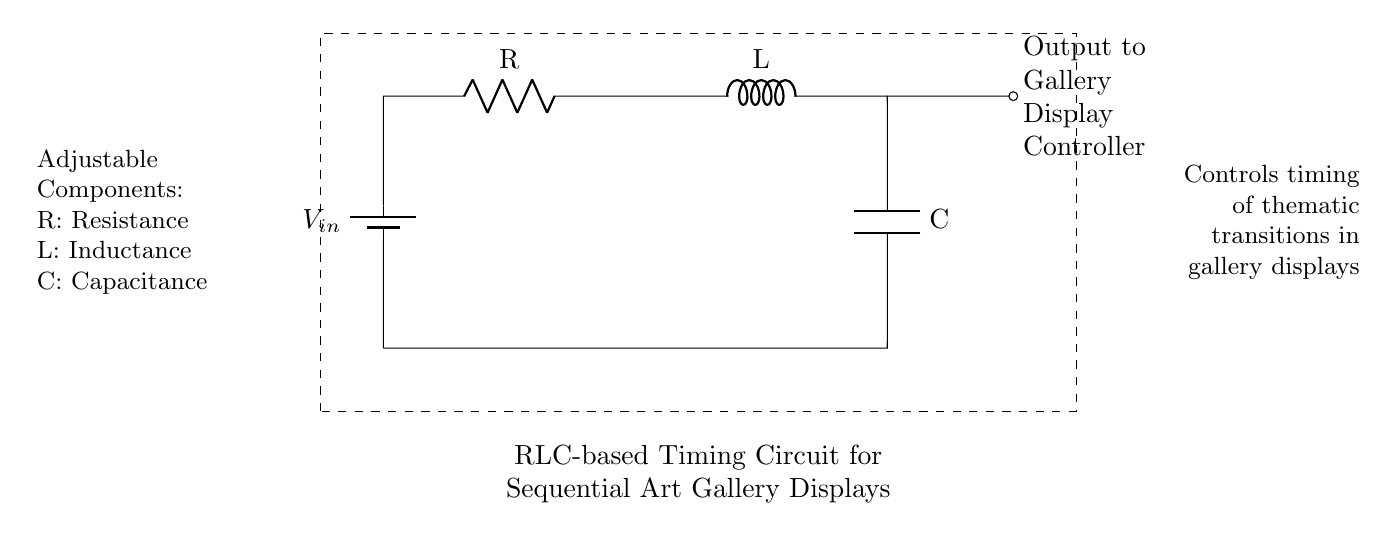What is the type of battery used in this circuit? The circuit diagram indicates the use of a battery symbol, which typically represents a direct current (DC) battery.
Answer: Battery What is connected in series with the battery? The circuit shows the battery connected in series with a resistor, followed by an inductor and a capacitor, forming a series RLC circuit.
Answer: Resistor What is the purpose of the RLC circuit in the context of the gallery? The diagram notes that this circuit controls the timing of thematic transitions in gallery displays, indicating its role in sequential display control.
Answer: Controls timing How many components are connected to the circuit? There are four key components visible in the circuit: one resistor, one inductor, one capacitor, and the battery.
Answer: Four What type of timing characteristic is expected from an RLC circuit? An RLC circuit exhibits oscillatory behavior, which can be used to create specific timing sequences through resonance effects.
Answer: Oscillatory How does changing the resistance affect the circuit's timing? Increasing the resistance in the circuit will generally slow down the time constant, resulting in a longer delay for the sequential displays to activate.
Answer: Slower timing What is the output of this circuit connected to? The output is connected to a display controller, which will take the timing signals generated by the RLC circuit to control the display sequence in the gallery.
Answer: Gallery Display Controller 